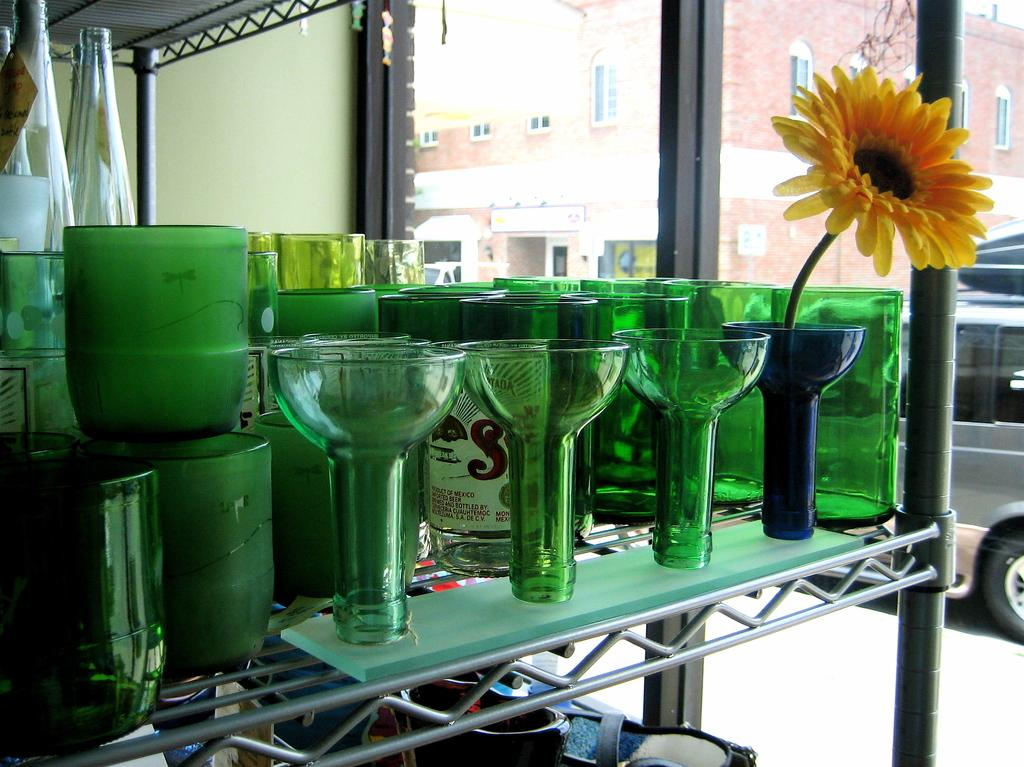What is located on the shelf in the image? There are objects on a shelf in the image. What type of containers can be seen in the image? There are bottles visible in the image. What type of structures are present in the image? There are buildings in the image. What type of transportation is visible in the image? There are vehicles in the image. What surface can be seen in the image that might be used for traveling? There is a road visible in the image. How many bears are wearing coats in the image? There are no bears present in the image, so it is not possible to determine how many bears might be wearing coats. 